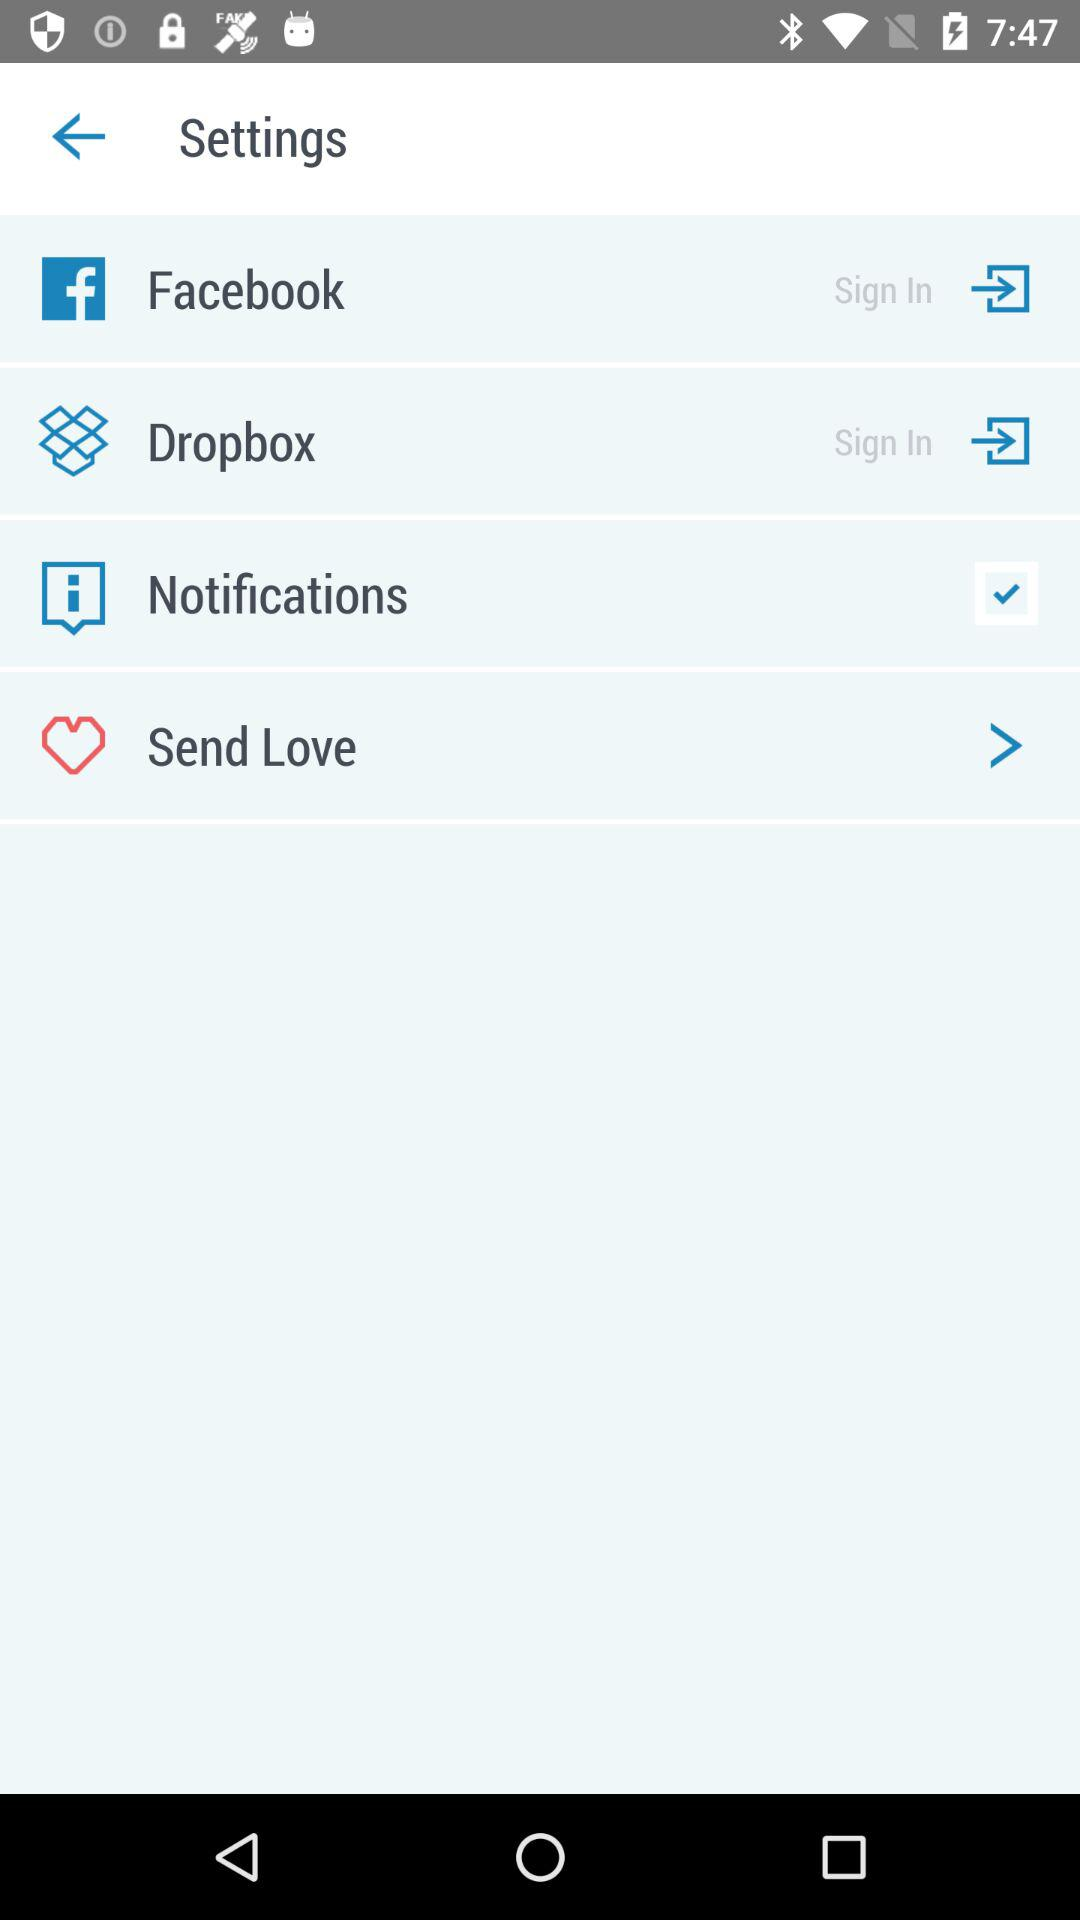What is the status of the notification? The status is on. 